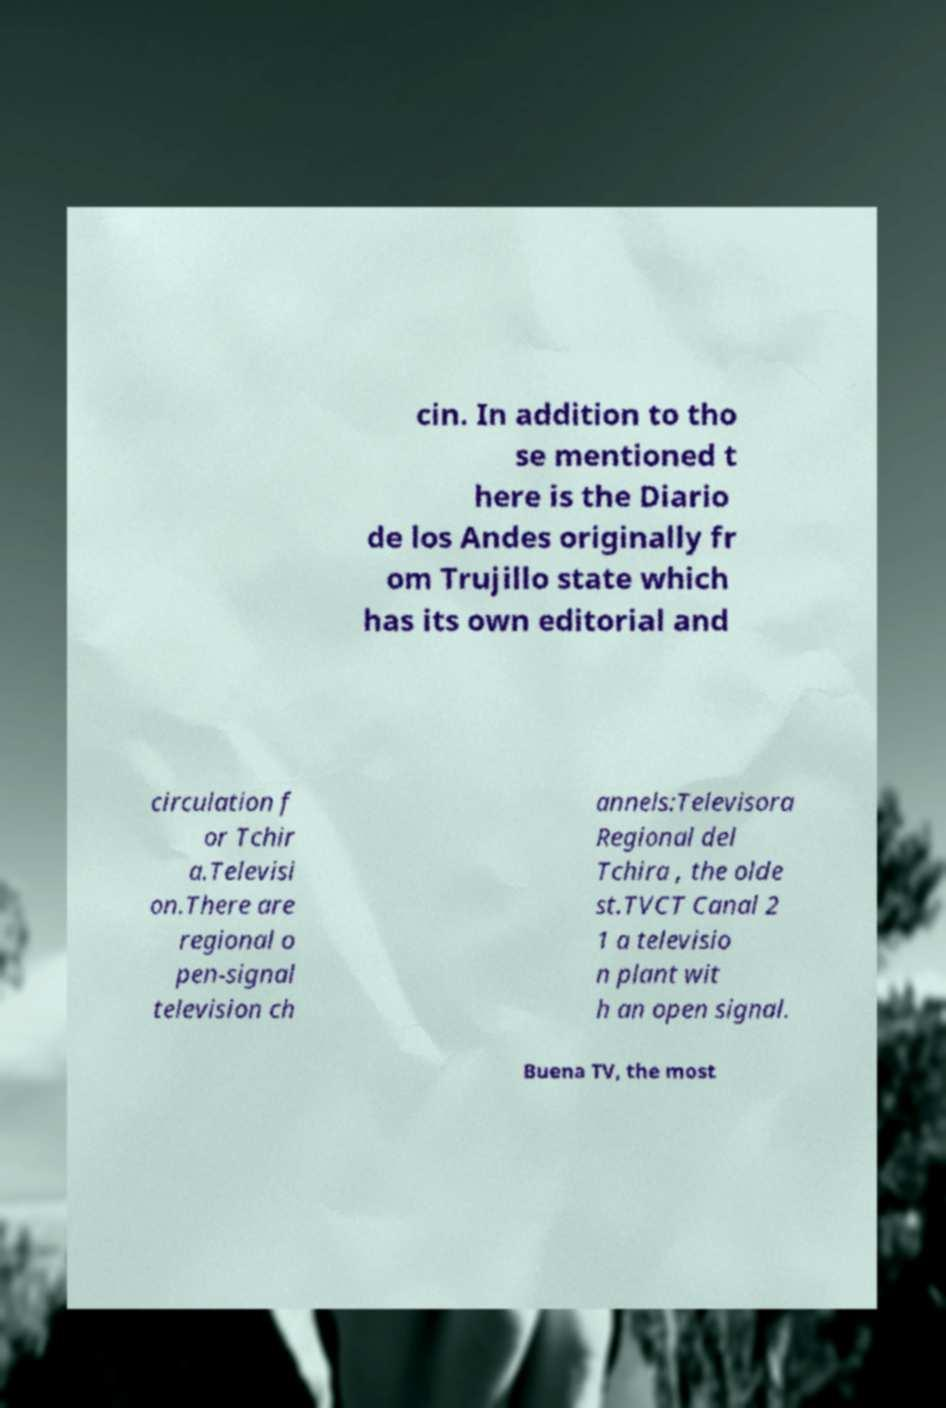Please read and relay the text visible in this image. What does it say? cin. In addition to tho se mentioned t here is the Diario de los Andes originally fr om Trujillo state which has its own editorial and circulation f or Tchir a.Televisi on.There are regional o pen-signal television ch annels:Televisora Regional del Tchira , the olde st.TVCT Canal 2 1 a televisio n plant wit h an open signal. Buena TV, the most 